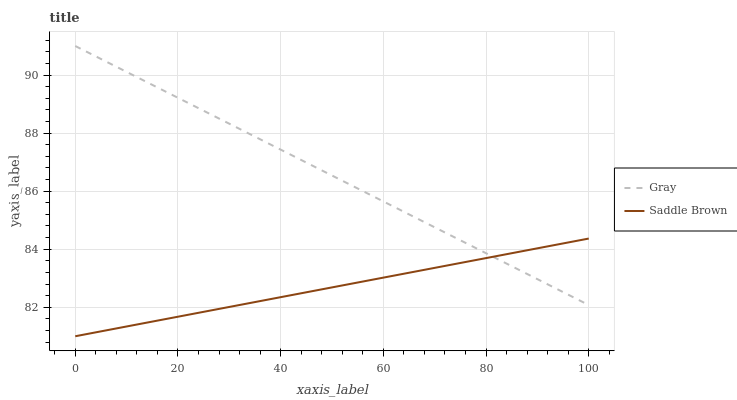Does Saddle Brown have the minimum area under the curve?
Answer yes or no. Yes. Does Gray have the maximum area under the curve?
Answer yes or no. Yes. Does Saddle Brown have the maximum area under the curve?
Answer yes or no. No. Is Saddle Brown the smoothest?
Answer yes or no. Yes. Is Gray the roughest?
Answer yes or no. Yes. Is Saddle Brown the roughest?
Answer yes or no. No. Does Saddle Brown have the lowest value?
Answer yes or no. Yes. Does Gray have the highest value?
Answer yes or no. Yes. Does Saddle Brown have the highest value?
Answer yes or no. No. Does Gray intersect Saddle Brown?
Answer yes or no. Yes. Is Gray less than Saddle Brown?
Answer yes or no. No. Is Gray greater than Saddle Brown?
Answer yes or no. No. 